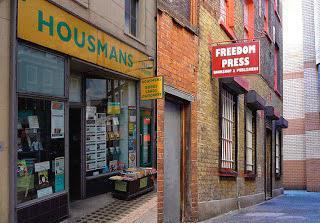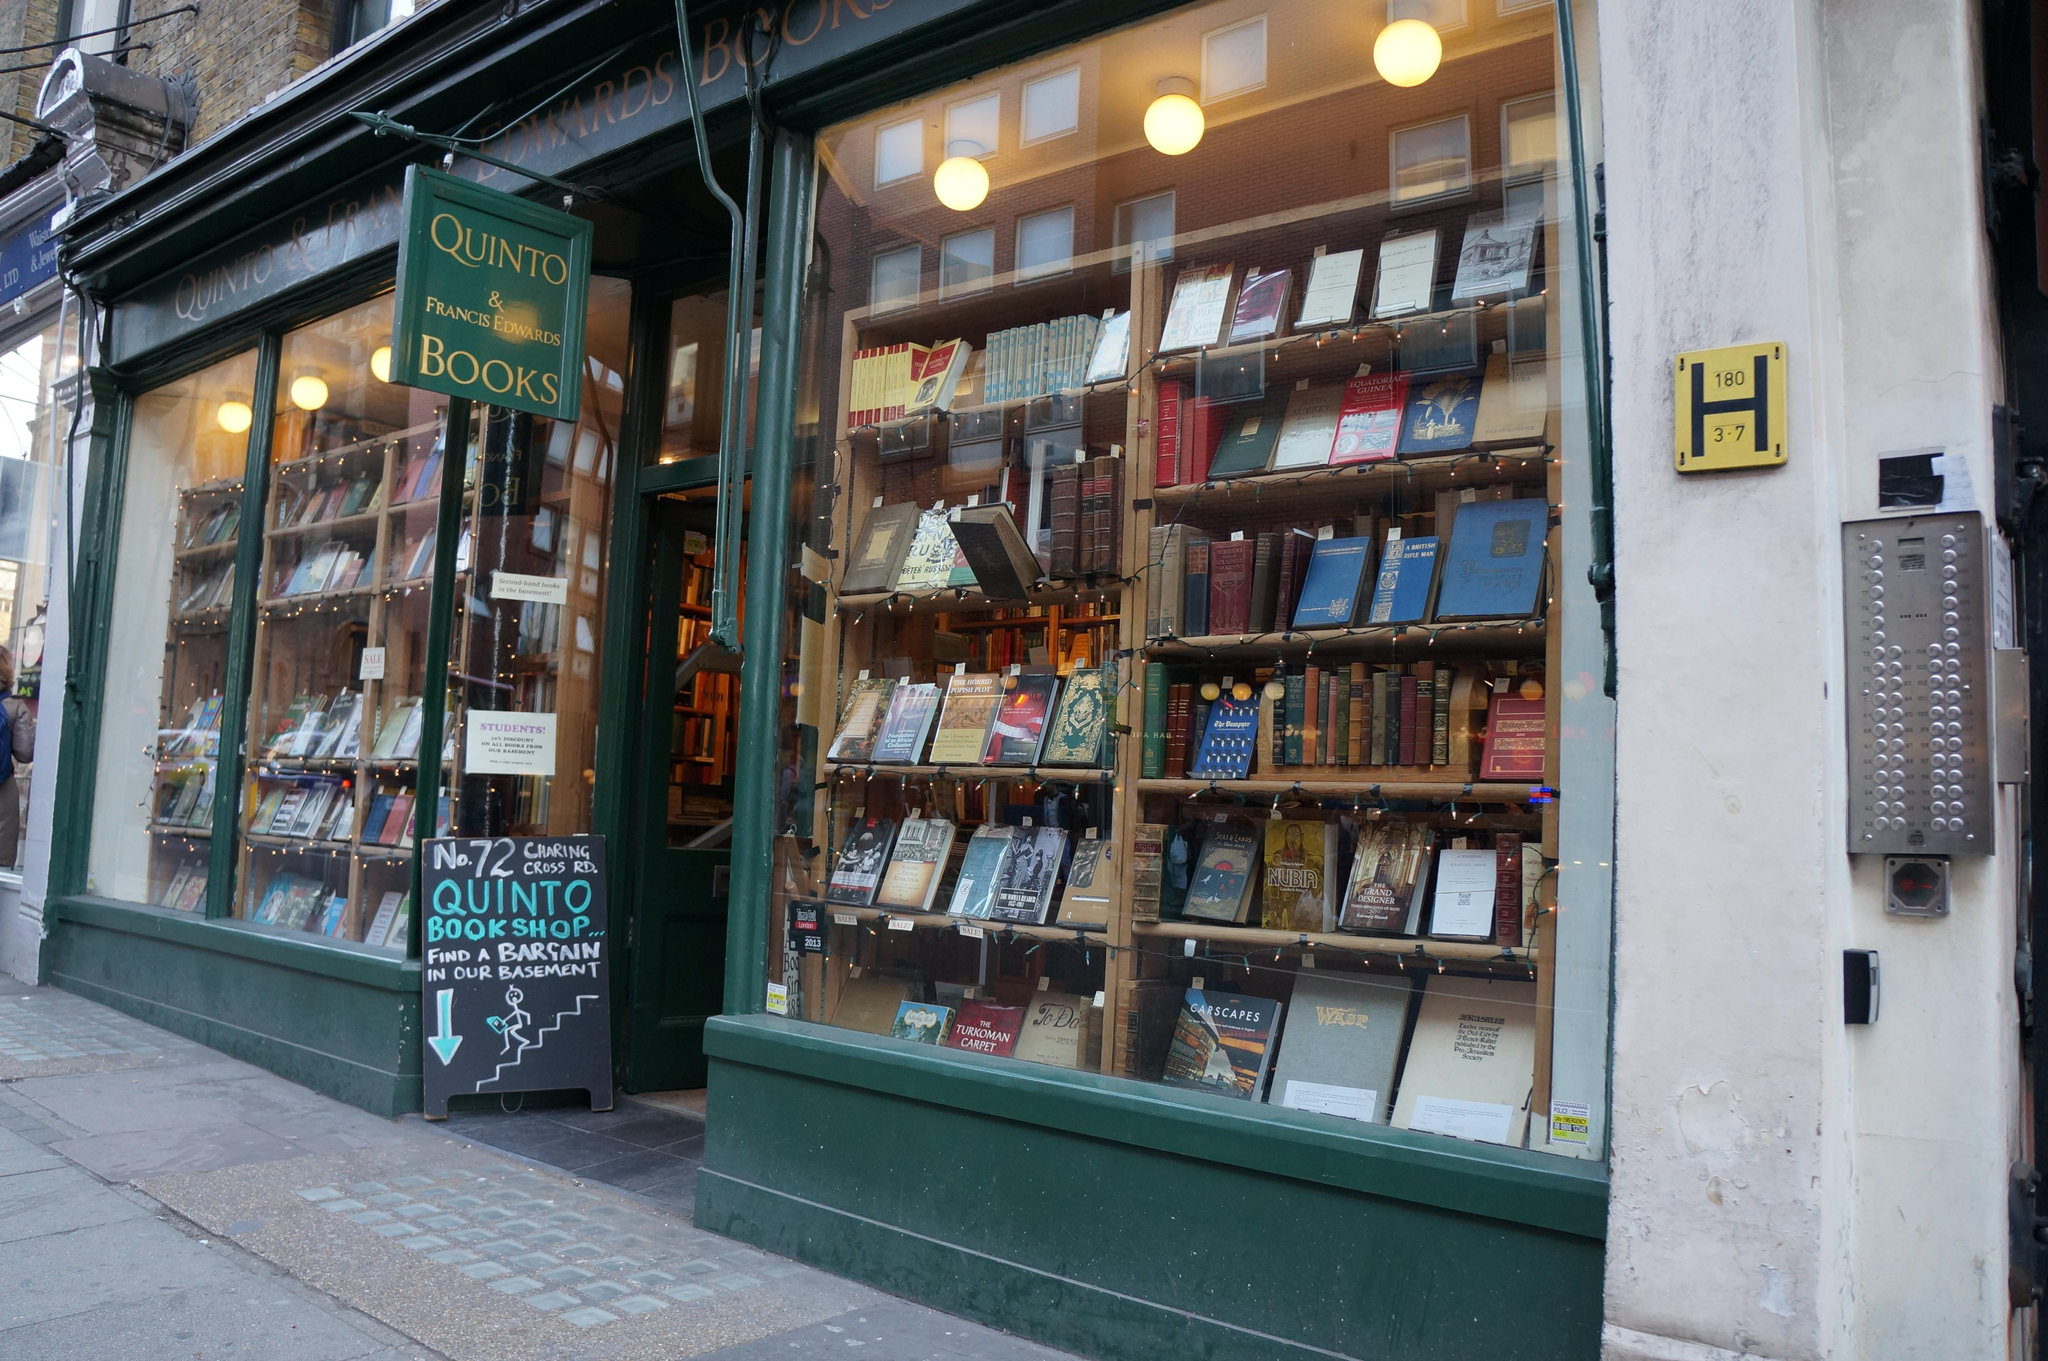The first image is the image on the left, the second image is the image on the right. Assess this claim about the two images: "A single two-wheeled vehicle is parked in front of a shop with red double doors.". Correct or not? Answer yes or no. No. The first image is the image on the left, the second image is the image on the right. Assess this claim about the two images: "The building on the right image has a closed red door while the building on the other side does not.". Correct or not? Answer yes or no. No. 